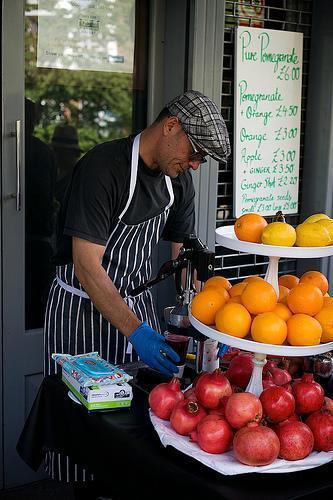How many lemons do you see?
Give a very brief answer. 4. 